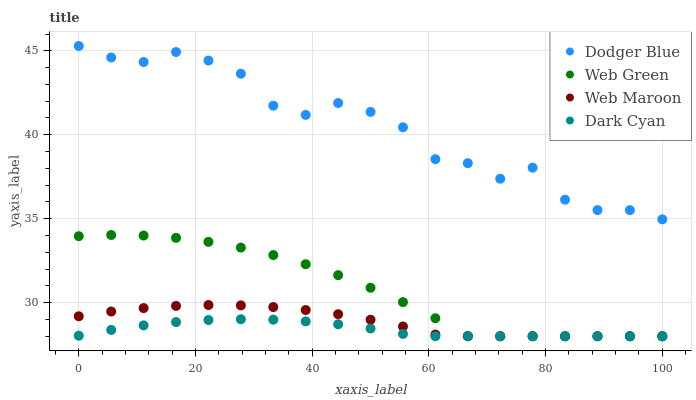Does Dark Cyan have the minimum area under the curve?
Answer yes or no. Yes. Does Dodger Blue have the maximum area under the curve?
Answer yes or no. Yes. Does Web Maroon have the minimum area under the curve?
Answer yes or no. No. Does Web Maroon have the maximum area under the curve?
Answer yes or no. No. Is Dark Cyan the smoothest?
Answer yes or no. Yes. Is Dodger Blue the roughest?
Answer yes or no. Yes. Is Web Maroon the smoothest?
Answer yes or no. No. Is Web Maroon the roughest?
Answer yes or no. No. Does Dark Cyan have the lowest value?
Answer yes or no. Yes. Does Dodger Blue have the lowest value?
Answer yes or no. No. Does Dodger Blue have the highest value?
Answer yes or no. Yes. Does Web Maroon have the highest value?
Answer yes or no. No. Is Web Green less than Dodger Blue?
Answer yes or no. Yes. Is Dodger Blue greater than Dark Cyan?
Answer yes or no. Yes. Does Web Maroon intersect Web Green?
Answer yes or no. Yes. Is Web Maroon less than Web Green?
Answer yes or no. No. Is Web Maroon greater than Web Green?
Answer yes or no. No. Does Web Green intersect Dodger Blue?
Answer yes or no. No. 